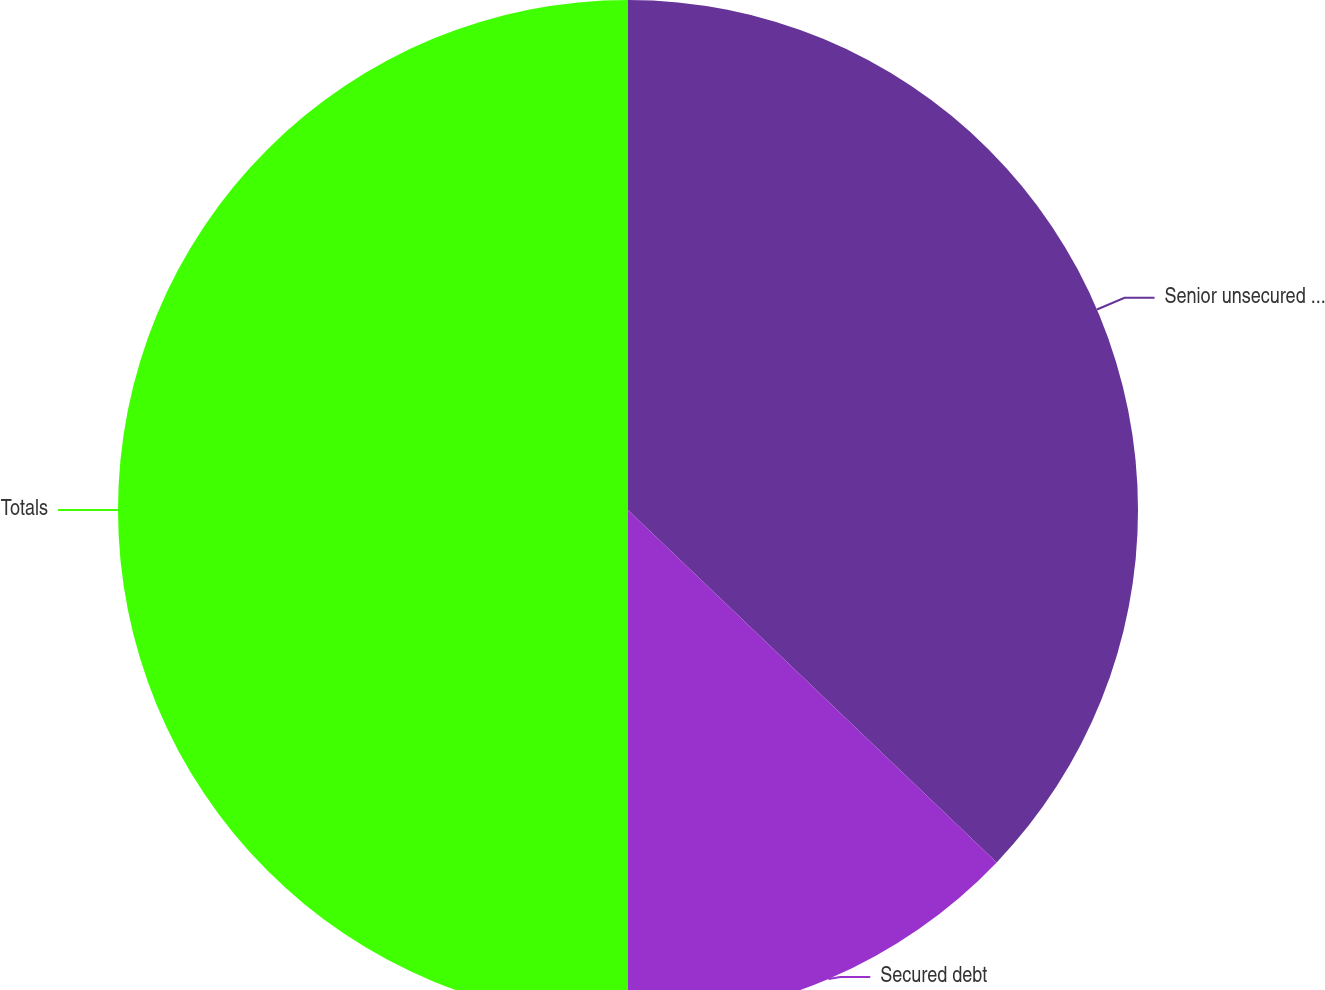Convert chart. <chart><loc_0><loc_0><loc_500><loc_500><pie_chart><fcel>Senior unsecured notes<fcel>Secured debt<fcel>Totals<nl><fcel>37.14%<fcel>12.86%<fcel>50.0%<nl></chart> 